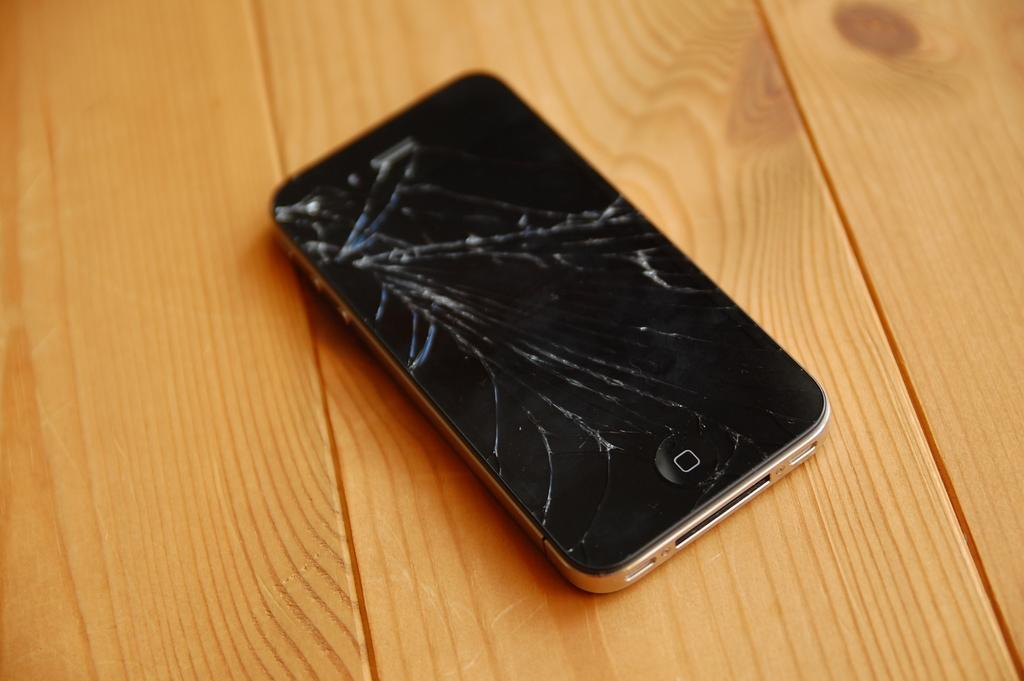<image>
Give a short and clear explanation of the subsequent image. A smart phone, in which you can only see the home button on the bottom, has a screen that is almost completely shattered. 